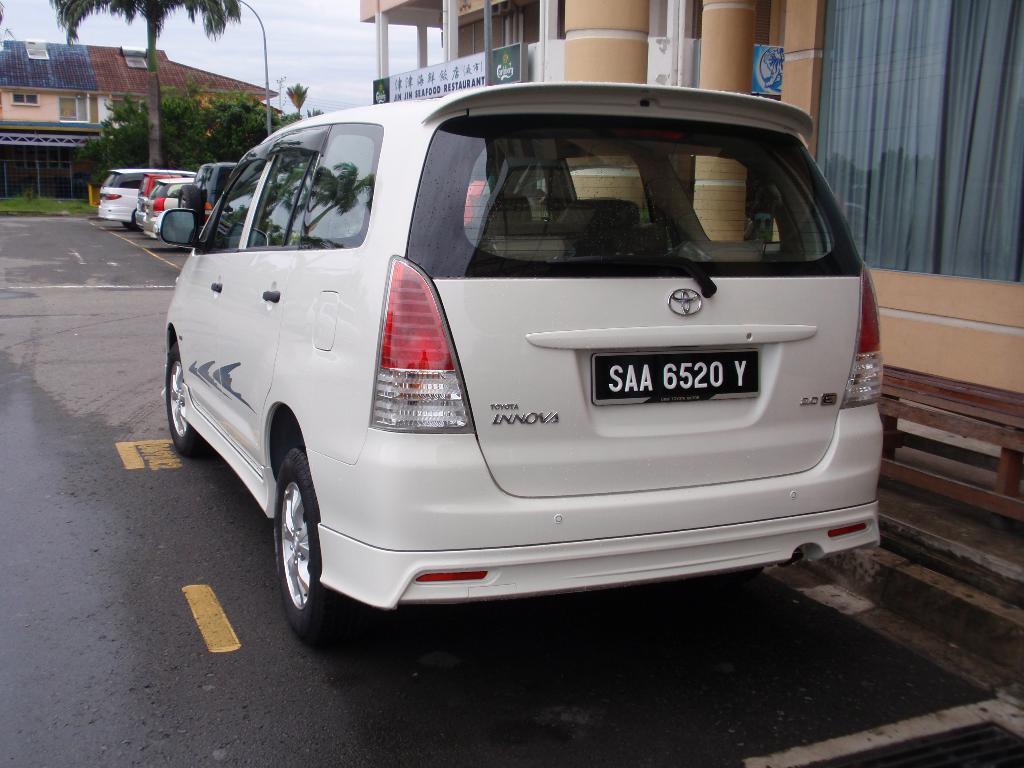What's this car number?
Your answer should be compact. Saa 6520 y. What is the model of this van?
Keep it short and to the point. Innova. 